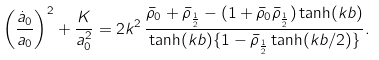Convert formula to latex. <formula><loc_0><loc_0><loc_500><loc_500>\left ( \frac { \dot { a } _ { 0 } } { a _ { 0 } } \right ) ^ { 2 } + \frac { K } { a _ { 0 } ^ { 2 } } = 2 k ^ { 2 } \, \frac { \bar { \rho } _ { 0 } + \bar { \rho } _ { \frac { 1 } { 2 } } - ( 1 + \bar { \rho } _ { 0 } \bar { \rho } _ { \frac { 1 } { 2 } } ) \tanh ( k b ) } { \tanh ( k b ) \{ 1 - \bar { \rho } _ { \frac { 1 } { 2 } } \tanh ( k b / 2 ) \} } .</formula> 